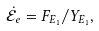<formula> <loc_0><loc_0><loc_500><loc_500>\dot { \mathcal { E } } _ { e } = F _ { E _ { 1 } } / Y _ { E _ { 1 } } ,</formula> 